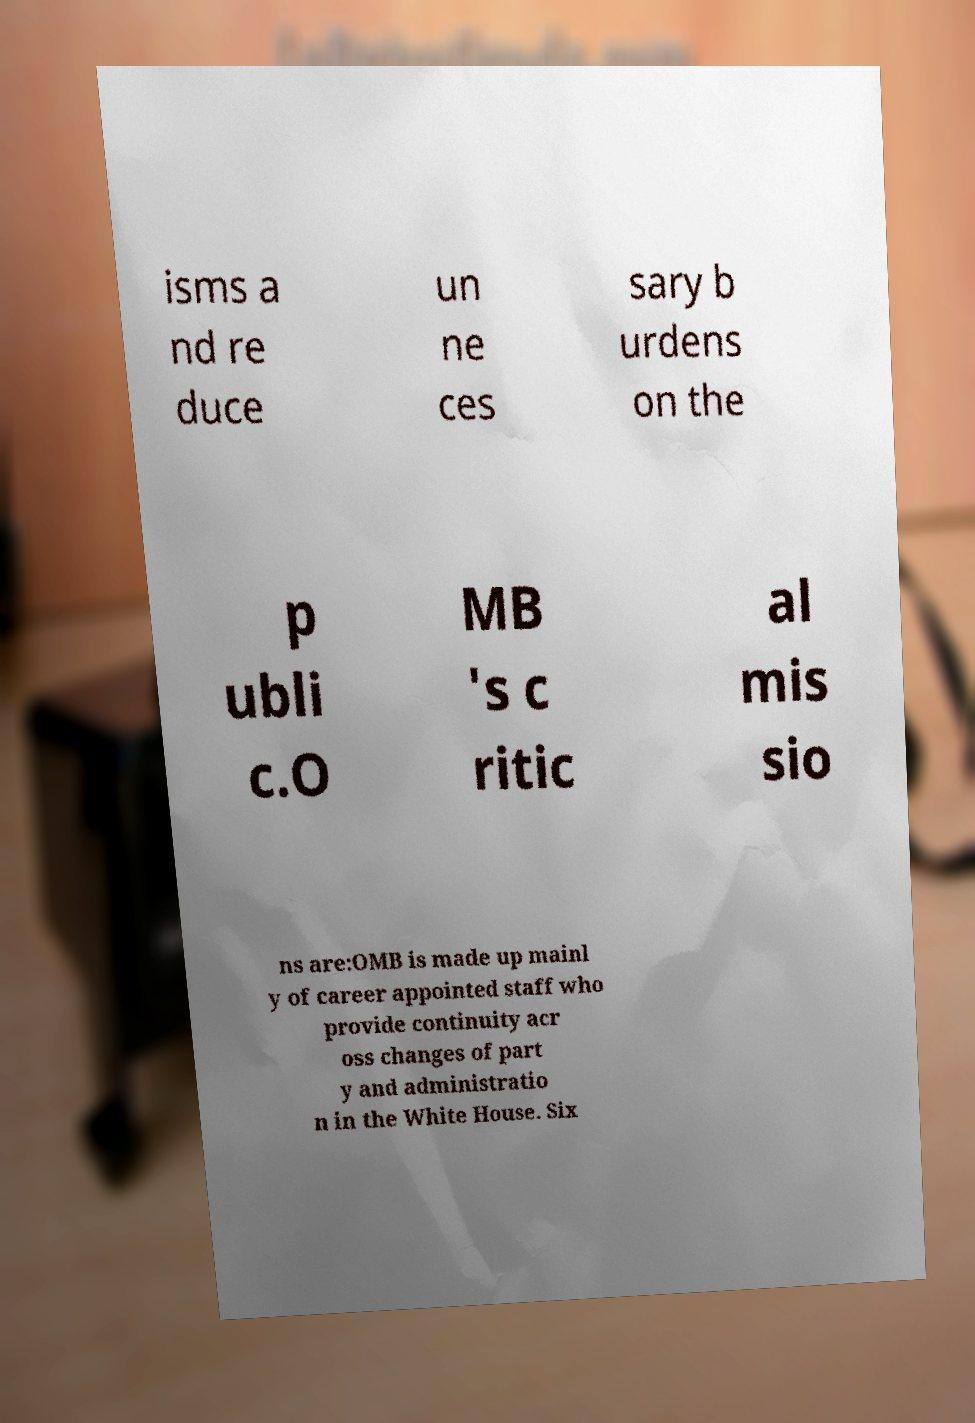I need the written content from this picture converted into text. Can you do that? isms a nd re duce un ne ces sary b urdens on the p ubli c.O MB 's c ritic al mis sio ns are:OMB is made up mainl y of career appointed staff who provide continuity acr oss changes of part y and administratio n in the White House. Six 